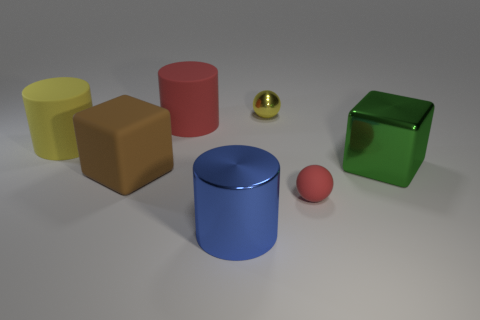Subtract all matte cylinders. How many cylinders are left? 1 Add 1 large green shiny cubes. How many objects exist? 8 Subtract all blue cylinders. How many cylinders are left? 2 Subtract all cylinders. How many objects are left? 4 Subtract 1 cylinders. How many cylinders are left? 2 Subtract all yellow cylinders. Subtract all red spheres. How many cylinders are left? 2 Subtract all gray spheres. How many red cubes are left? 0 Subtract all brown matte cubes. Subtract all green metallic things. How many objects are left? 5 Add 2 green metallic cubes. How many green metallic cubes are left? 3 Add 3 brown matte cubes. How many brown matte cubes exist? 4 